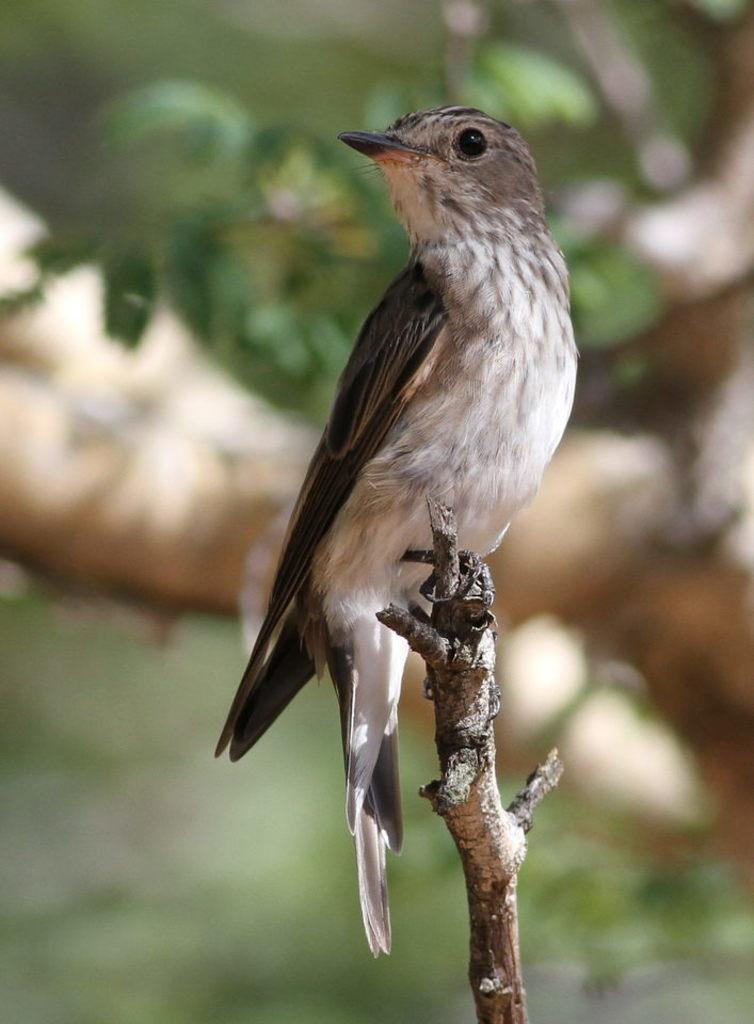Please provide a concise description of this image. In this image a bird is standing on the stem. Behind it there are few leaves. 